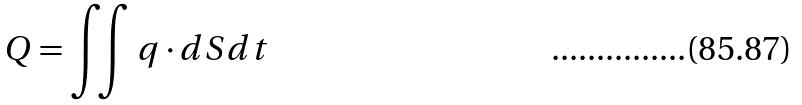<formula> <loc_0><loc_0><loc_500><loc_500>Q = \iint q \cdot d S d t</formula> 